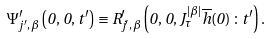<formula> <loc_0><loc_0><loc_500><loc_500>\Psi _ { j ^ { \prime } , \, \beta } ^ { \prime } \left ( 0 , \, 0 , \, t ^ { \prime } \right ) \equiv R _ { j ^ { \prime } , \, \beta } ^ { \prime } \left ( 0 , \, 0 , \, J _ { \tau } ^ { | \beta | } \overline { h } ( 0 ) \, \colon t ^ { \prime } \right ) .</formula> 